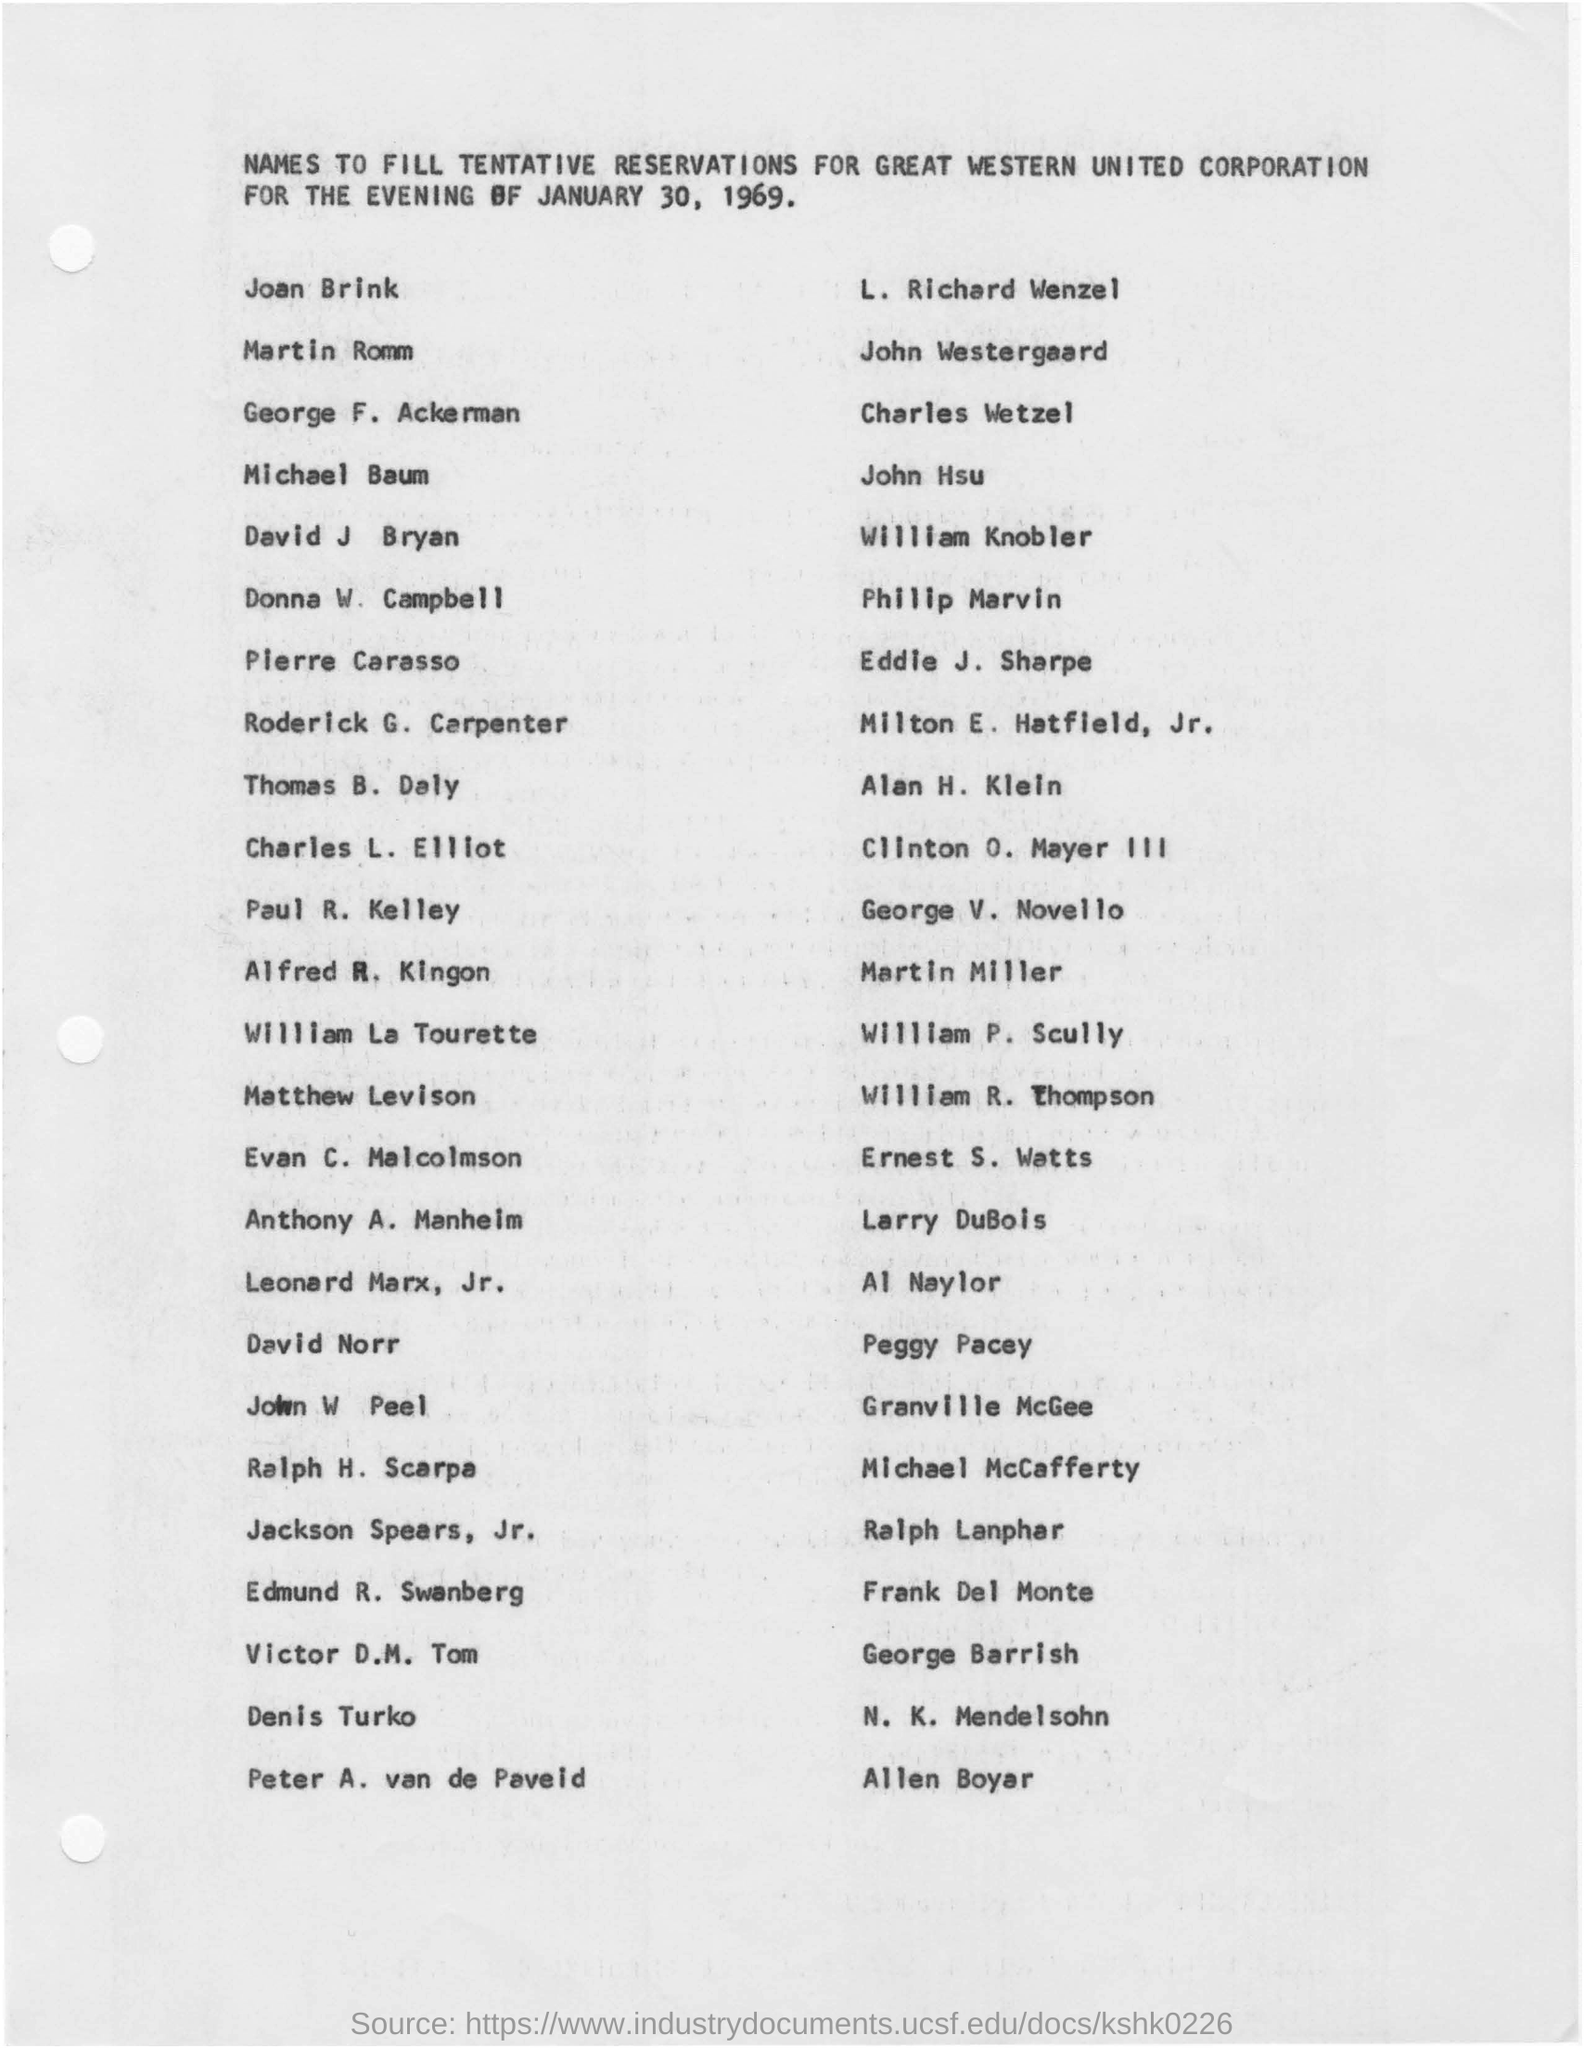What is the purpose of the tentative reservations made?
Provide a succinct answer. FOR GREAT WESTERN UNITED CORPORATION FOR THE EVENING OF JANUARY 30, 1969. Which day is the tentative reservations made for?
Offer a very short reply. JANUARY 30, 1969. 